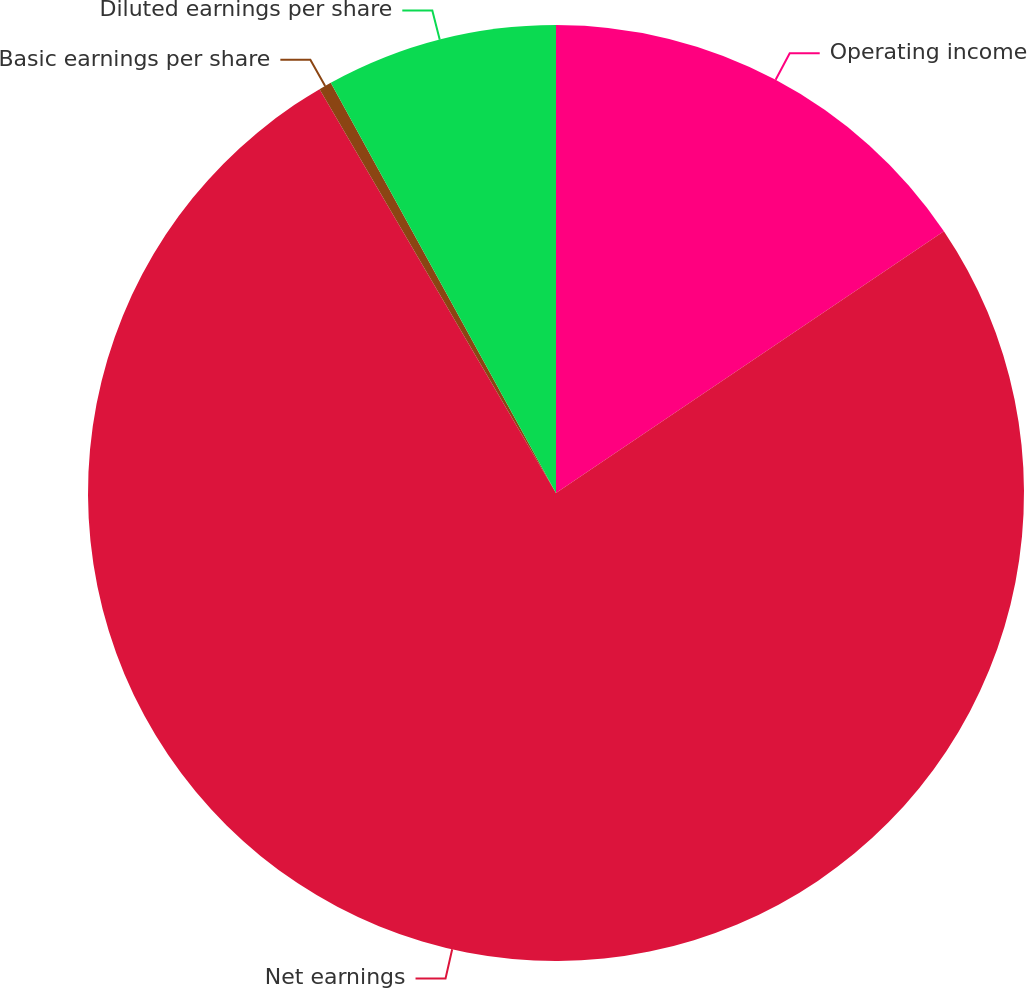Convert chart to OTSL. <chart><loc_0><loc_0><loc_500><loc_500><pie_chart><fcel>Operating income<fcel>Net earnings<fcel>Basic earnings per share<fcel>Diluted earnings per share<nl><fcel>15.55%<fcel>76.02%<fcel>0.44%<fcel>7.99%<nl></chart> 